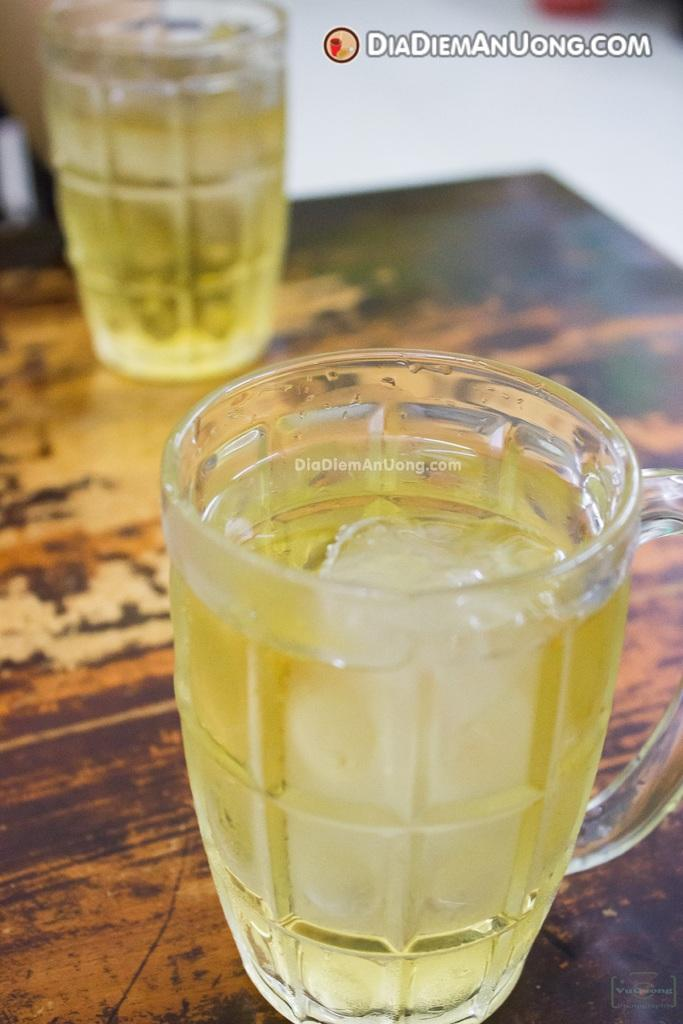What can be seen in the image related to beverages? There are two glasses of liquid in the image. What is the surface on which the glasses are placed? The glasses are on a wooden table. Can you describe any additional visual elements in the image? There is a watermark visible in the image. What is located at the top of the image? There is a logo and text at the top of the image. How many pies are present on the wooden table in the image? There are no pies visible in the image; it only shows two glasses of liquid on a wooden table. 